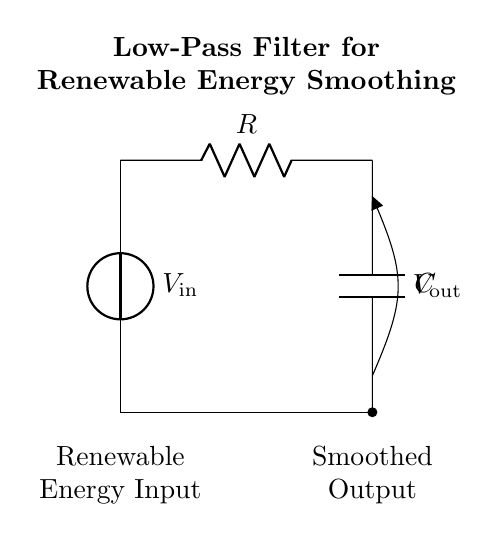What is the type of filter represented in this circuit? The circuit represents a low-pass filter, as it allows low-frequency signals to pass while attenuating high-frequency signals. This is evident from the configuration of the resistor and capacitor in series with the voltage source.
Answer: low-pass filter What is the purpose of the capacitor in this circuit? The capacitor in this low-pass filter smooths the fluctuations in the voltage output by storing and releasing charge, which helps to smooth the power output from renewable sources. This is essential for maintaining a stable voltage level.
Answer: smoothing voltage What component represents renewable energy input? The voltage source labeled as V_in represents the renewable energy input in this circuit, indicating where the power originates before being processed by the filter.
Answer: V_in What are the labels for the output voltage and input voltage? The output voltage is labeled as V_out and the input voltage as V_in. This indicates the points where the voltages are applied in the circuit and signifies the processing sequence from input to output.
Answer: V_out and V_in What happens to high-frequency signals in this circuit? High-frequency signals are attenuated or reduced in amplitude as they pass through the low-pass filter, allowing only low-frequency signals to appear in the output. This is due to the reactive nature of the capacitor, which resists changes in voltage.
Answer: attenuated What is the main function of the resistor in this circuit? The resistor limits the current flowing through the circuit and helps set the cutoff frequency along with the capacitor, which determines the effective filtering of the signal based on required specifications.
Answer: limit current What is the relationship between resistance, capacitance, and cutoff frequency? The cutoff frequency (fc) of the low-pass filter is inversely proportional to the product of resistance (R) and capacitance (C), expressed in the formula fc = 1/(2πRC). This relationship determines the filter's effectiveness at distinguishing between low and high frequencies.
Answer: inverse proportionality 